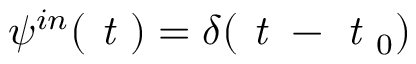Convert formula to latex. <formula><loc_0><loc_0><loc_500><loc_500>\psi ^ { i n } ( t ) = \delta ( t - t _ { 0 } )</formula> 